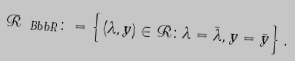Convert formula to latex. <formula><loc_0><loc_0><loc_500><loc_500>{ \mathcal { R } } _ { \ B b b R } \colon = \left \{ ( \lambda , y ) \in { \mathcal { R } } \colon \lambda = { \bar { \lambda } } , y = { \bar { y } } \right \} .</formula> 